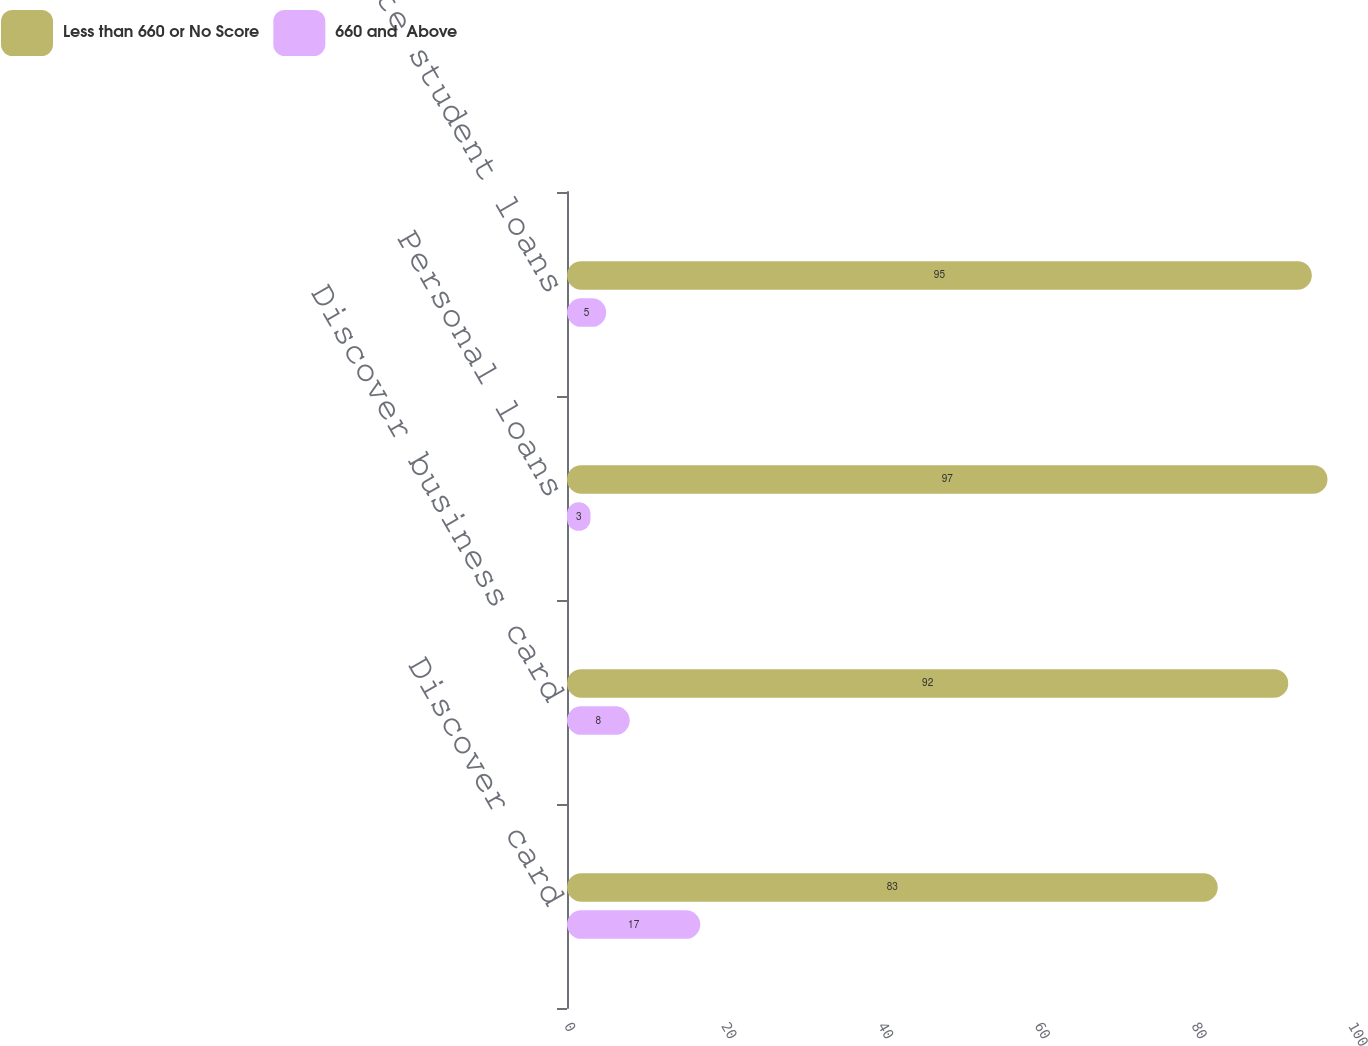<chart> <loc_0><loc_0><loc_500><loc_500><stacked_bar_chart><ecel><fcel>Discover card<fcel>Discover business card<fcel>Personal loans<fcel>Private student loans<nl><fcel>Less than 660 or No Score<fcel>83<fcel>92<fcel>97<fcel>95<nl><fcel>660 and  Above<fcel>17<fcel>8<fcel>3<fcel>5<nl></chart> 